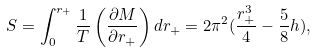Convert formula to latex. <formula><loc_0><loc_0><loc_500><loc_500>S = \int ^ { r _ { + } } _ { 0 } \frac { 1 } { T } \left ( \frac { \partial M } { \partial r _ { + } } \right ) d r _ { + } = 2 \pi ^ { 2 } ( \frac { r _ { + } ^ { 3 } } { 4 } - \frac { 5 } { 8 } h ) ,</formula> 